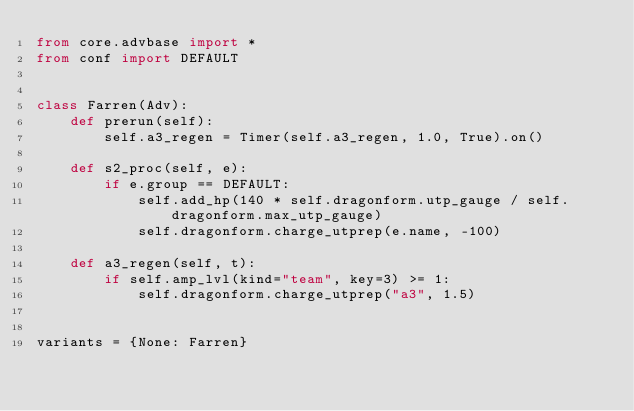<code> <loc_0><loc_0><loc_500><loc_500><_Python_>from core.advbase import *
from conf import DEFAULT


class Farren(Adv):
    def prerun(self):
        self.a3_regen = Timer(self.a3_regen, 1.0, True).on()

    def s2_proc(self, e):
        if e.group == DEFAULT:
            self.add_hp(140 * self.dragonform.utp_gauge / self.dragonform.max_utp_gauge)
            self.dragonform.charge_utprep(e.name, -100)

    def a3_regen(self, t):
        if self.amp_lvl(kind="team", key=3) >= 1:
            self.dragonform.charge_utprep("a3", 1.5)


variants = {None: Farren}
</code> 